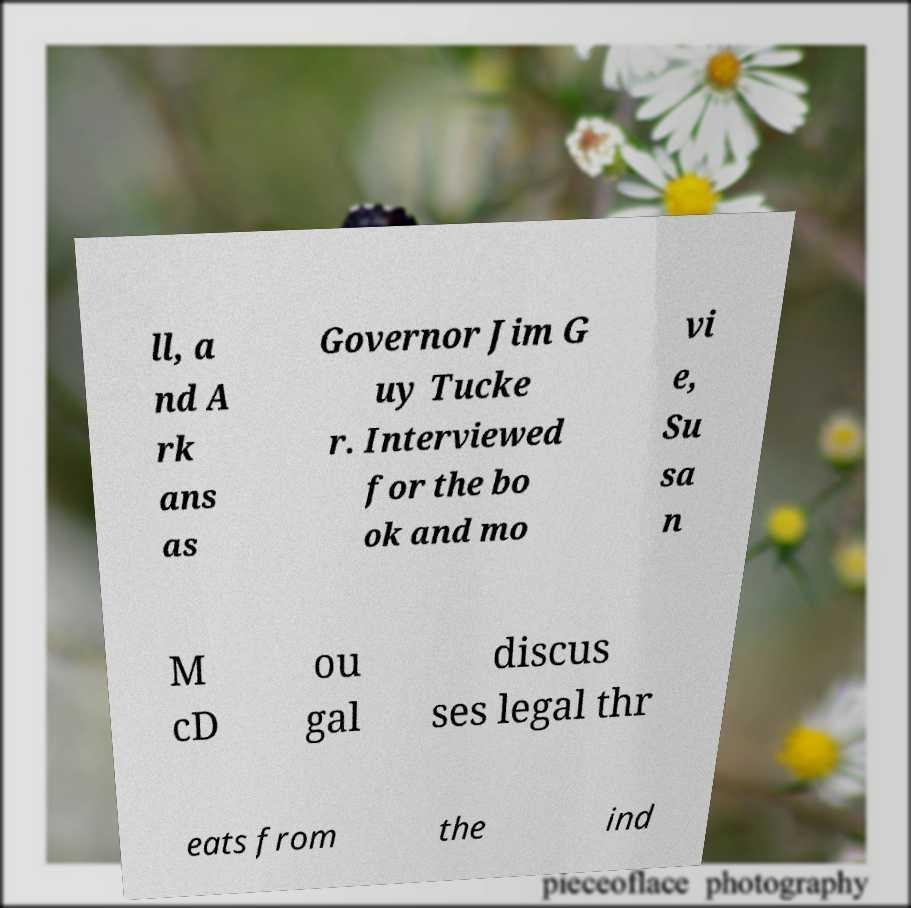For documentation purposes, I need the text within this image transcribed. Could you provide that? ll, a nd A rk ans as Governor Jim G uy Tucke r. Interviewed for the bo ok and mo vi e, Su sa n M cD ou gal discus ses legal thr eats from the ind 